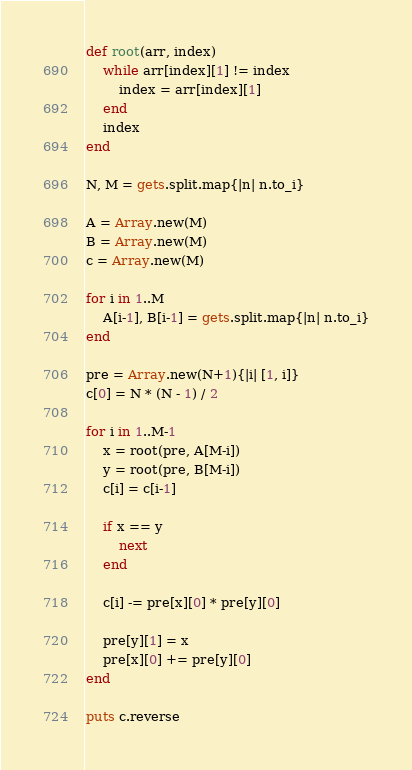Convert code to text. <code><loc_0><loc_0><loc_500><loc_500><_Ruby_>def root(arr, index)
    while arr[index][1] != index
        index = arr[index][1]
    end
    index
end

N, M = gets.split.map{|n| n.to_i}

A = Array.new(M)
B = Array.new(M)
c = Array.new(M)

for i in 1..M
    A[i-1], B[i-1] = gets.split.map{|n| n.to_i}
end

pre = Array.new(N+1){|i| [1, i]}
c[0] = N * (N - 1) / 2

for i in 1..M-1
    x = root(pre, A[M-i])
    y = root(pre, B[M-i])
    c[i] = c[i-1]

    if x == y
        next
    end

    c[i] -= pre[x][0] * pre[y][0]

    pre[y][1] = x
    pre[x][0] += pre[y][0]
end

puts c.reverse</code> 